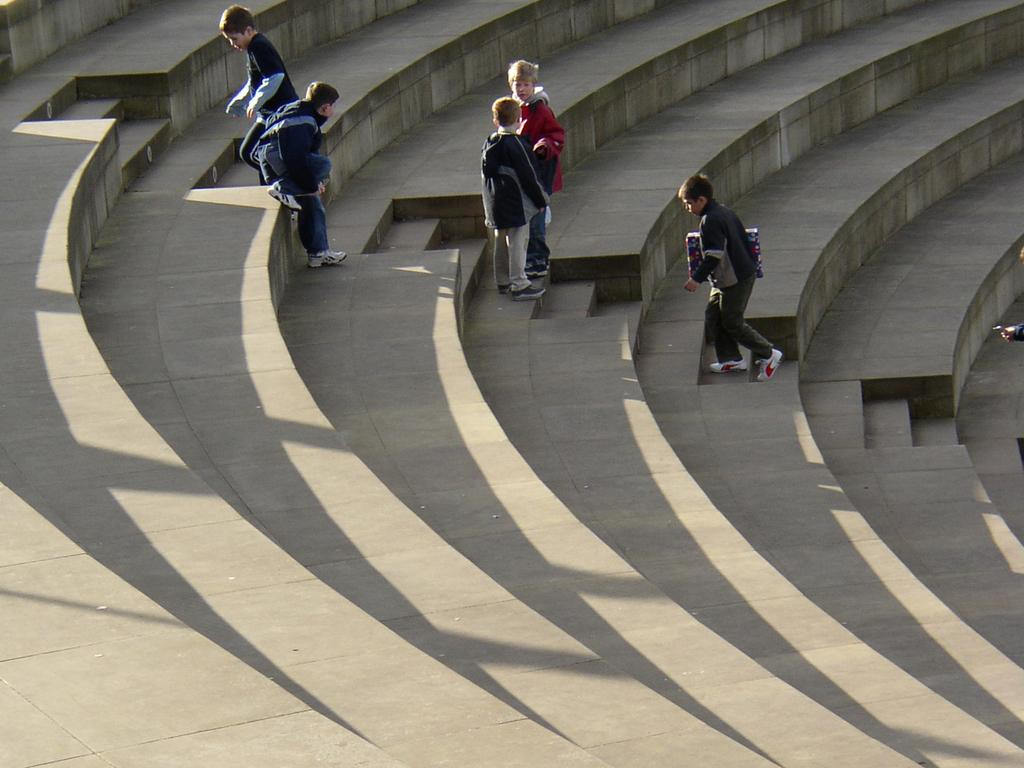How many people are in the image? There is a group of people in the image, but the exact number is not specified. Where are the people located in the image? The people are on the steps in the image. What type of lettuce is being served to the people on the steps in the image? There is no lettuce or any food visible in the image; it only shows a group of people on the steps. 